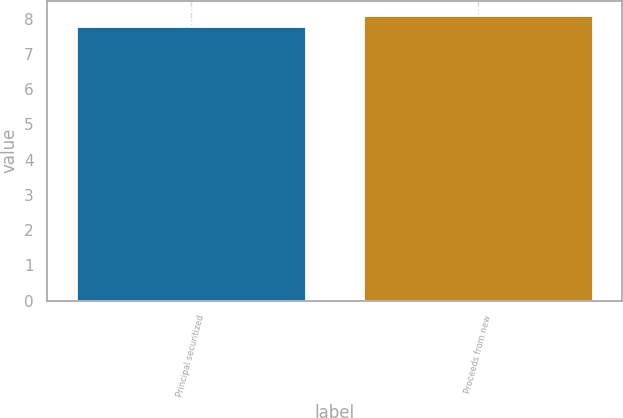Convert chart. <chart><loc_0><loc_0><loc_500><loc_500><bar_chart><fcel>Principal securitized<fcel>Proceeds from new<nl><fcel>7.8<fcel>8.1<nl></chart> 